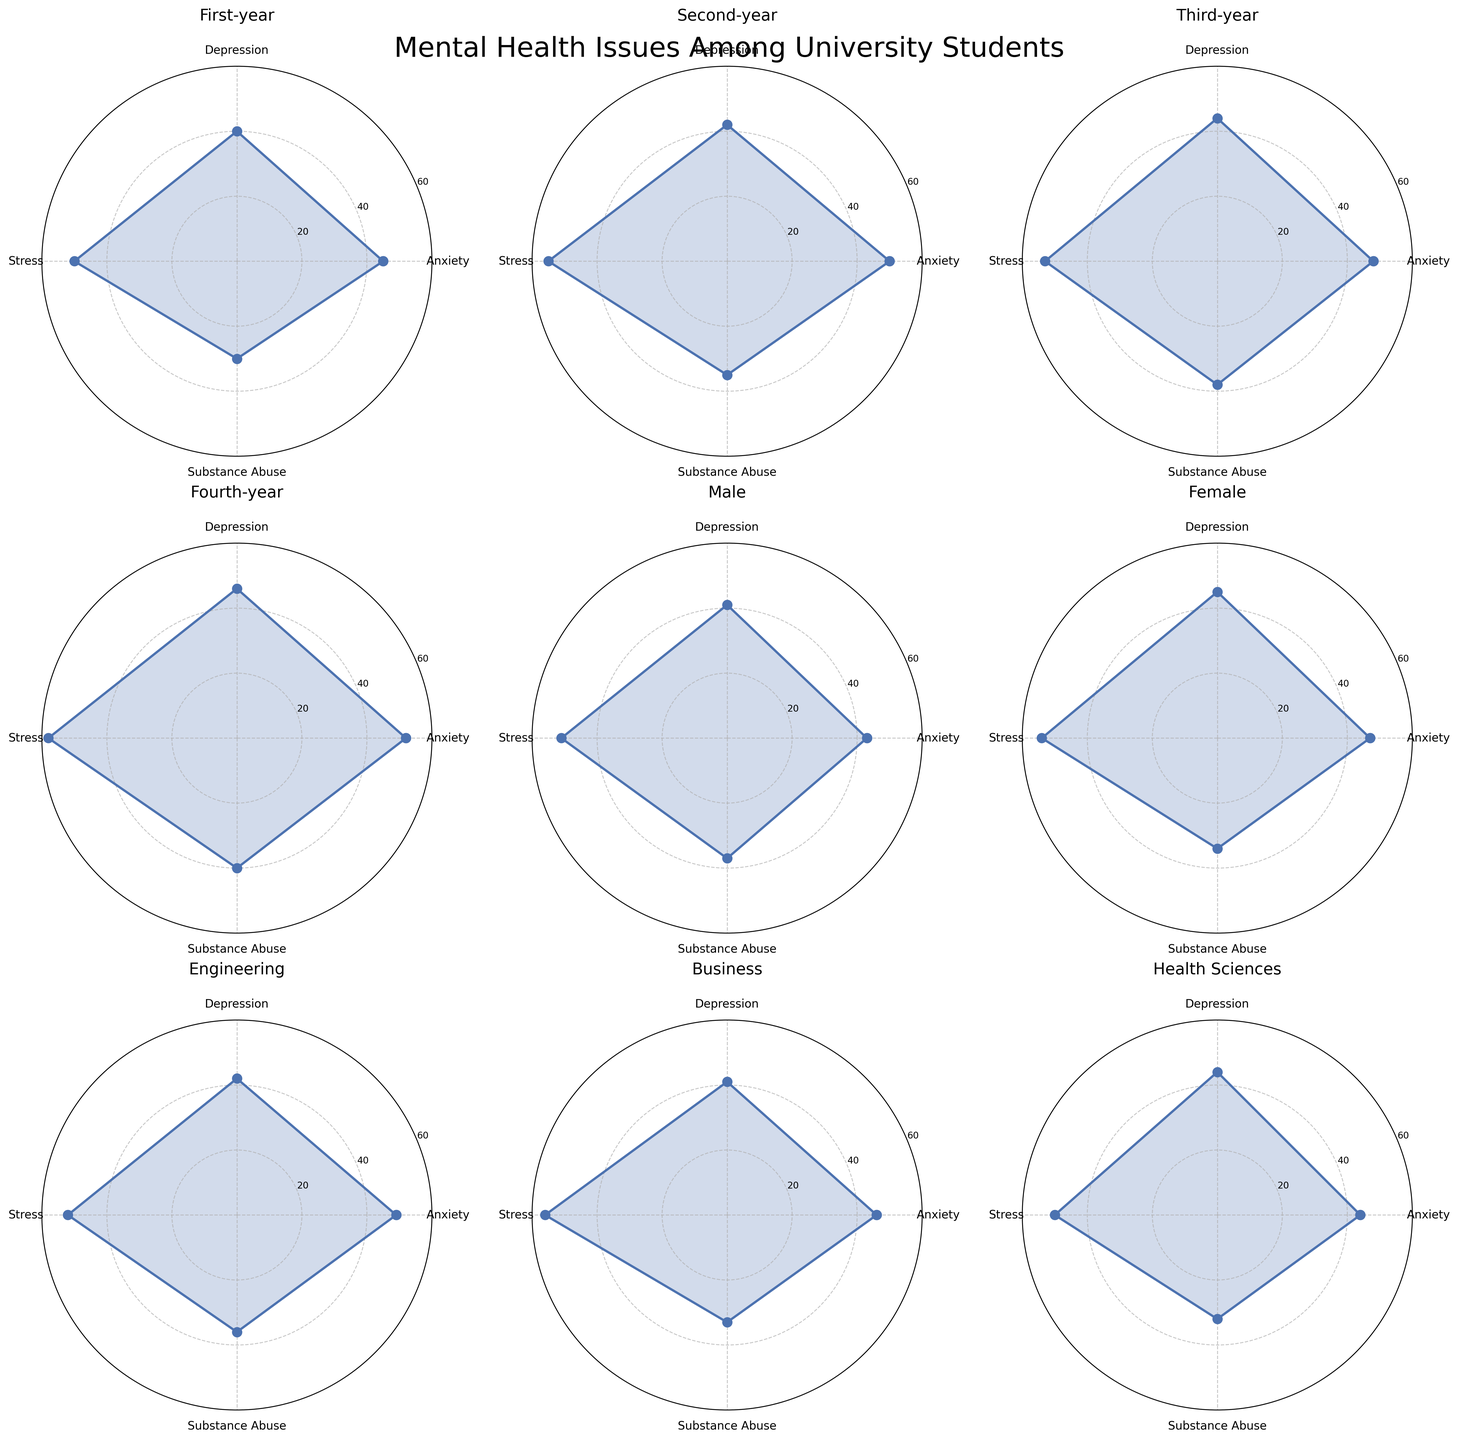What are the main mental health issues represented in the radar chart? The radar chart features labels for Anxiety, Depression, Stress, and Substance Abuse.
Answer: Anxiety, Depression, Stress, Substance Abuse Which category has the highest level of Substance Abuse? The subplots show the highest value for Substance Abuse for International Students, which reaches 41.
Answer: International Students How do Anxiety and Depression levels compare between Male and Female students? The chart shows Male students with Anxiety at 43 and Depression at 41, and Female students with Anxiety at 47 and Depression at 45.
Answer: Female students have higher levels Which year of study shows the maximum Stress levels? By comparing the Stress levels across all years, the Fourth-year students exhibit the highest stress at 58.
Answer: Fourth-year What's the Difference in Anxiety levels between First-year and Fourth-year students? Anxiety levels are 45 for First-year and 52 for Fourth-year students. The difference is 52 - 45 = 7.
Answer: 7 Which group has the lowest Substance Abuse level? The lowest value for Substance Abuse is 30 found in First-year students.
Answer: First-year What is the average Depression level for Engineering and Business students? Depression levels are 42 for Engineering and 41 for Business. The average is (42 + 41) / 2 = 41.5.
Answer: 41.5 Are International Students more stressed compared to Domestic Students? The stress level for International Students is 59 and for Domestic Students is 52.
Answer: Yes Which category between Employed and Unemployed Students has a higher Depression level? Depression for Employed Students is 42, and for Unemployed Students, it is 45.
Answer: Unemployed Students What is the highest Anxiety level observed among the shown categories? The highest Anxiety level is 53 seen in International Students.
Answer: 53 